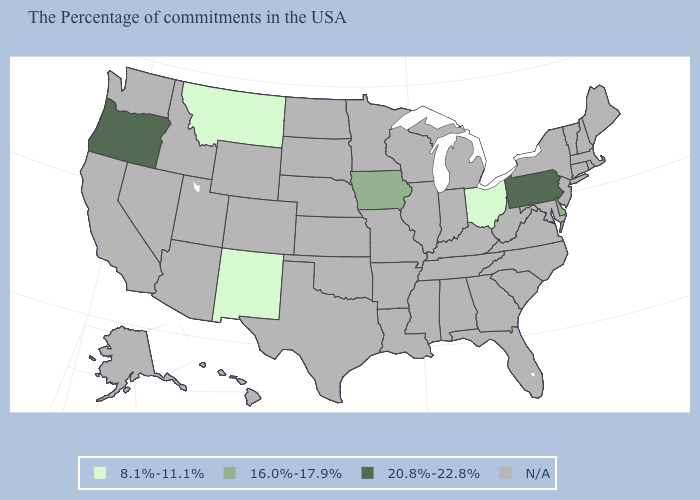Among the states that border Ohio , which have the lowest value?
Keep it brief. Pennsylvania. Which states hav the highest value in the MidWest?
Write a very short answer. Iowa. What is the value of Rhode Island?
Keep it brief. N/A. Name the states that have a value in the range 16.0%-17.9%?
Answer briefly. Delaware, Iowa. Name the states that have a value in the range 16.0%-17.9%?
Keep it brief. Delaware, Iowa. What is the lowest value in the Northeast?
Concise answer only. 20.8%-22.8%. What is the value of Colorado?
Short answer required. N/A. Does the map have missing data?
Write a very short answer. Yes. What is the value of Pennsylvania?
Be succinct. 20.8%-22.8%. What is the value of North Carolina?
Short answer required. N/A. Name the states that have a value in the range N/A?
Short answer required. Maine, Massachusetts, Rhode Island, New Hampshire, Vermont, Connecticut, New York, New Jersey, Maryland, Virginia, North Carolina, South Carolina, West Virginia, Florida, Georgia, Michigan, Kentucky, Indiana, Alabama, Tennessee, Wisconsin, Illinois, Mississippi, Louisiana, Missouri, Arkansas, Minnesota, Kansas, Nebraska, Oklahoma, Texas, South Dakota, North Dakota, Wyoming, Colorado, Utah, Arizona, Idaho, Nevada, California, Washington, Alaska, Hawaii. Which states hav the highest value in the West?
Be succinct. Oregon. 